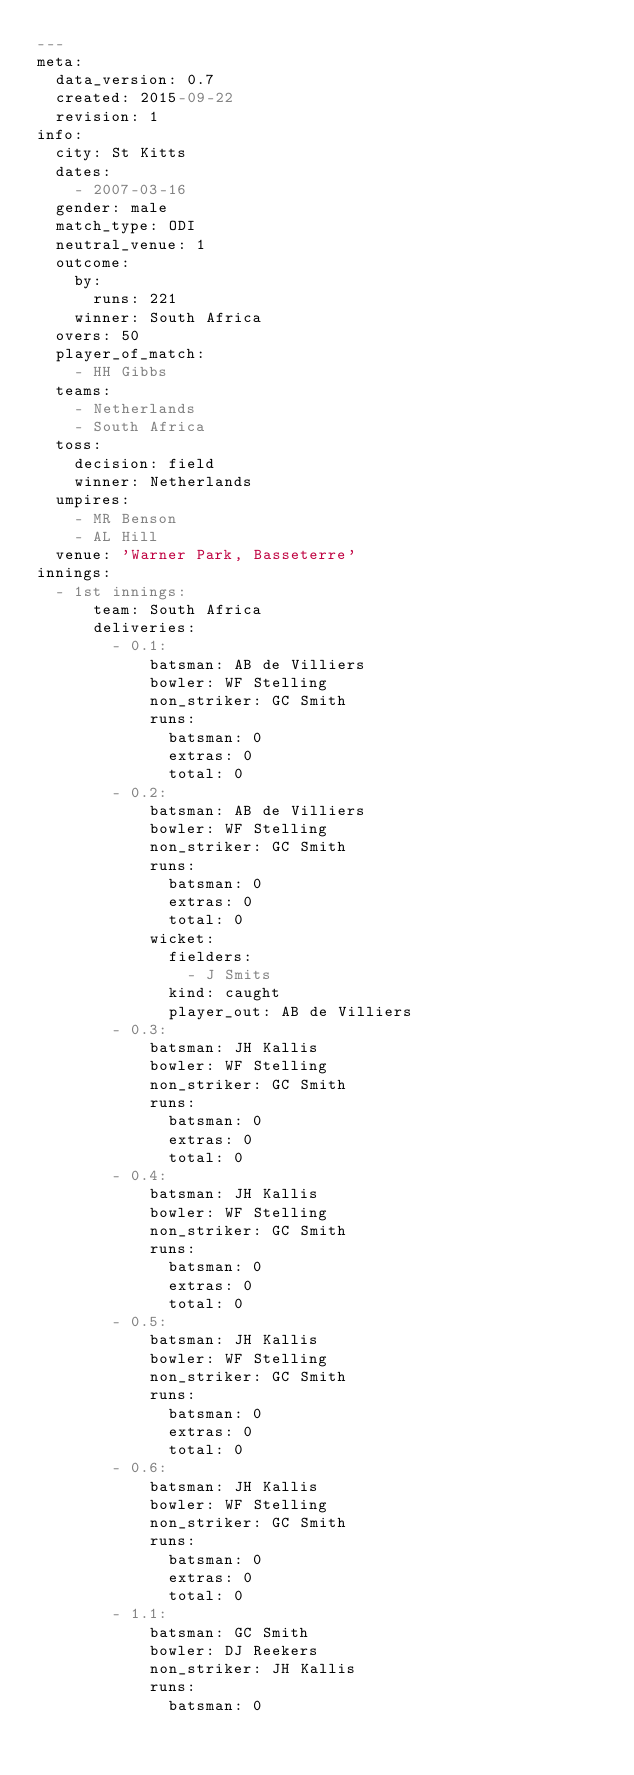Convert code to text. <code><loc_0><loc_0><loc_500><loc_500><_YAML_>---
meta:
  data_version: 0.7
  created: 2015-09-22
  revision: 1
info:
  city: St Kitts
  dates:
    - 2007-03-16
  gender: male
  match_type: ODI
  neutral_venue: 1
  outcome:
    by:
      runs: 221
    winner: South Africa
  overs: 50
  player_of_match:
    - HH Gibbs
  teams:
    - Netherlands
    - South Africa
  toss:
    decision: field
    winner: Netherlands
  umpires:
    - MR Benson
    - AL Hill
  venue: 'Warner Park, Basseterre'
innings:
  - 1st innings:
      team: South Africa
      deliveries:
        - 0.1:
            batsman: AB de Villiers
            bowler: WF Stelling
            non_striker: GC Smith
            runs:
              batsman: 0
              extras: 0
              total: 0
        - 0.2:
            batsman: AB de Villiers
            bowler: WF Stelling
            non_striker: GC Smith
            runs:
              batsman: 0
              extras: 0
              total: 0
            wicket:
              fielders:
                - J Smits
              kind: caught
              player_out: AB de Villiers
        - 0.3:
            batsman: JH Kallis
            bowler: WF Stelling
            non_striker: GC Smith
            runs:
              batsman: 0
              extras: 0
              total: 0
        - 0.4:
            batsman: JH Kallis
            bowler: WF Stelling
            non_striker: GC Smith
            runs:
              batsman: 0
              extras: 0
              total: 0
        - 0.5:
            batsman: JH Kallis
            bowler: WF Stelling
            non_striker: GC Smith
            runs:
              batsman: 0
              extras: 0
              total: 0
        - 0.6:
            batsman: JH Kallis
            bowler: WF Stelling
            non_striker: GC Smith
            runs:
              batsman: 0
              extras: 0
              total: 0
        - 1.1:
            batsman: GC Smith
            bowler: DJ Reekers
            non_striker: JH Kallis
            runs:
              batsman: 0</code> 